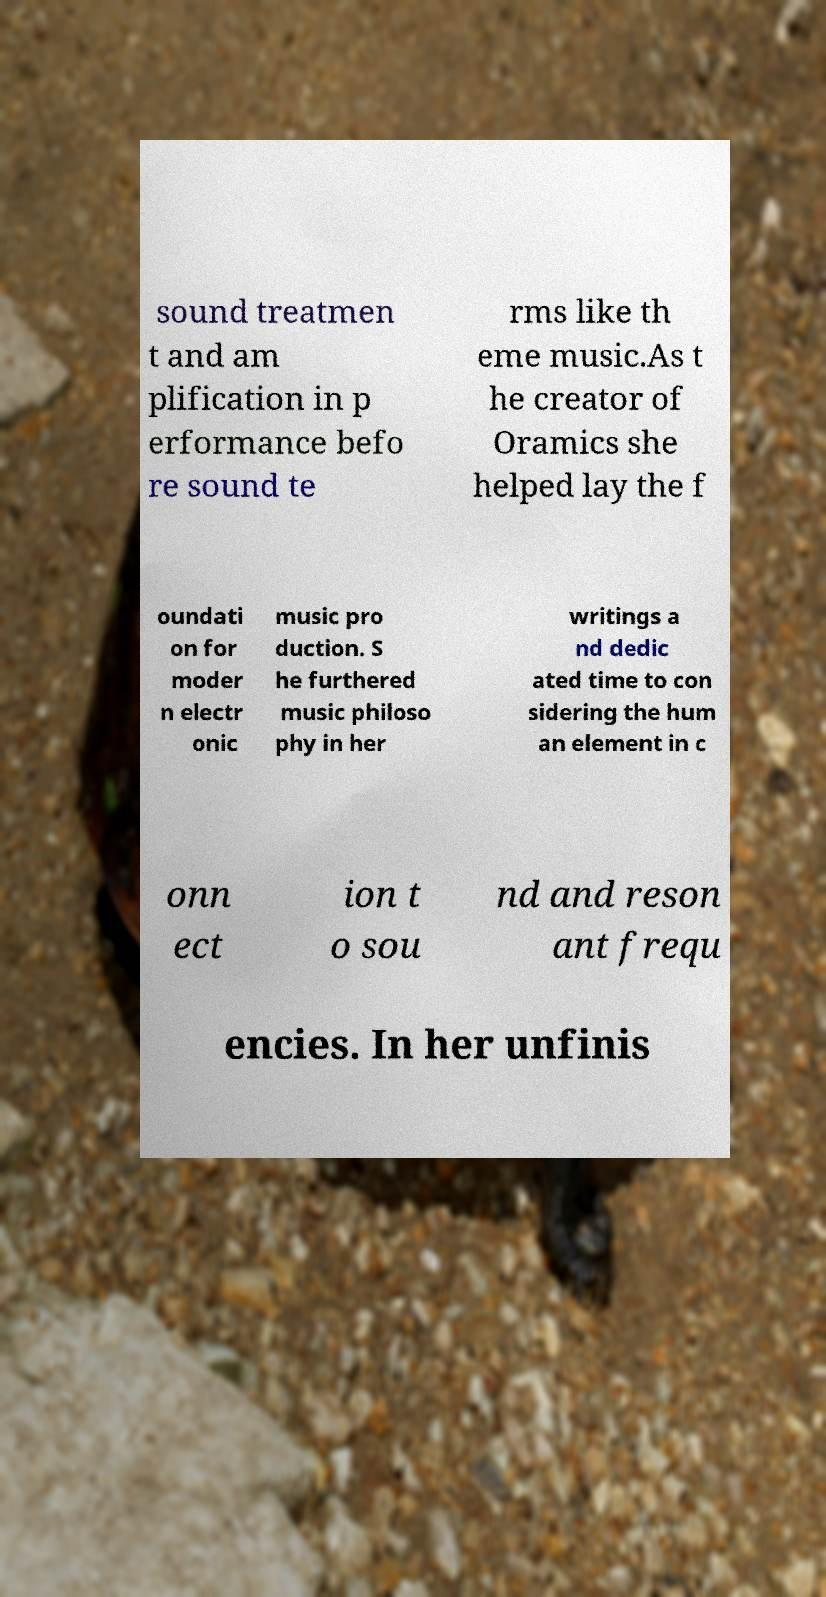Please read and relay the text visible in this image. What does it say? sound treatmen t and am plification in p erformance befo re sound te rms like th eme music.As t he creator of Oramics she helped lay the f oundati on for moder n electr onic music pro duction. S he furthered music philoso phy in her writings a nd dedic ated time to con sidering the hum an element in c onn ect ion t o sou nd and reson ant frequ encies. In her unfinis 